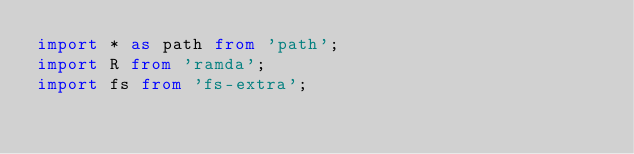<code> <loc_0><loc_0><loc_500><loc_500><_TypeScript_>import * as path from 'path';
import R from 'ramda';
import fs from 'fs-extra';</code> 